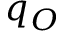<formula> <loc_0><loc_0><loc_500><loc_500>q _ { O }</formula> 